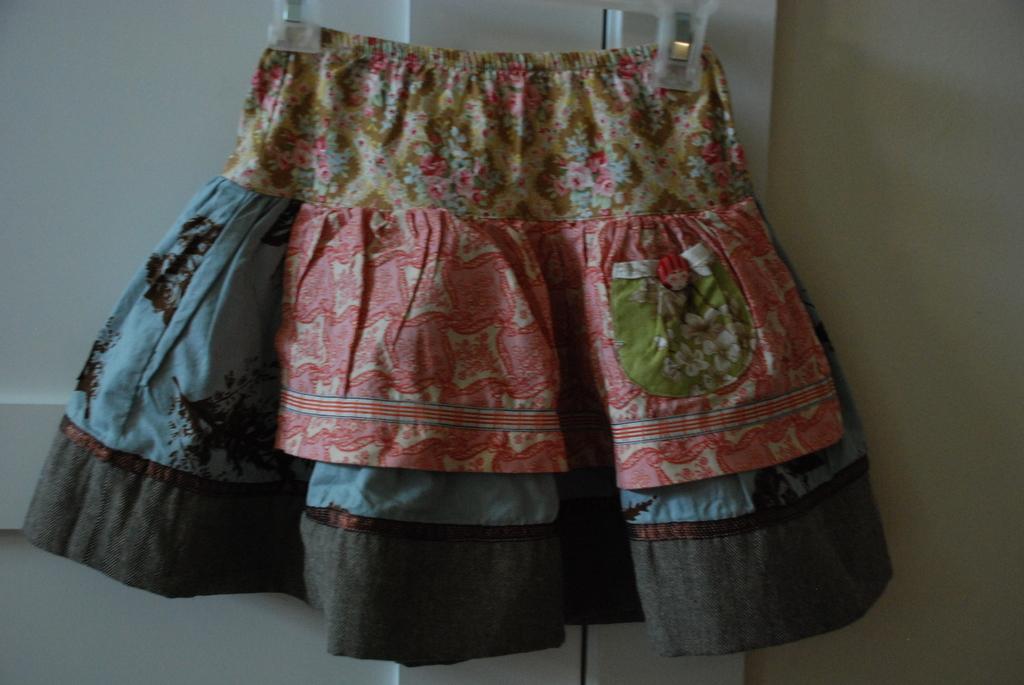Describe this image in one or two sentences. In the image there is a skirt hanged in front of the door and on the right side there is a wall. 